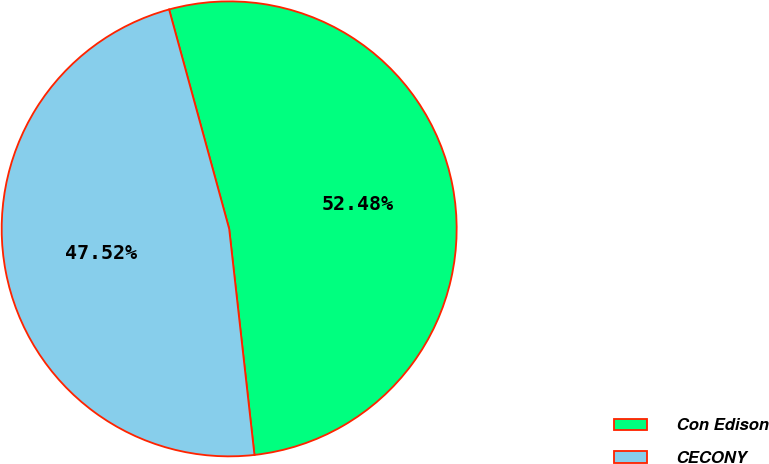Convert chart. <chart><loc_0><loc_0><loc_500><loc_500><pie_chart><fcel>Con Edison<fcel>CECONY<nl><fcel>52.48%<fcel>47.52%<nl></chart> 